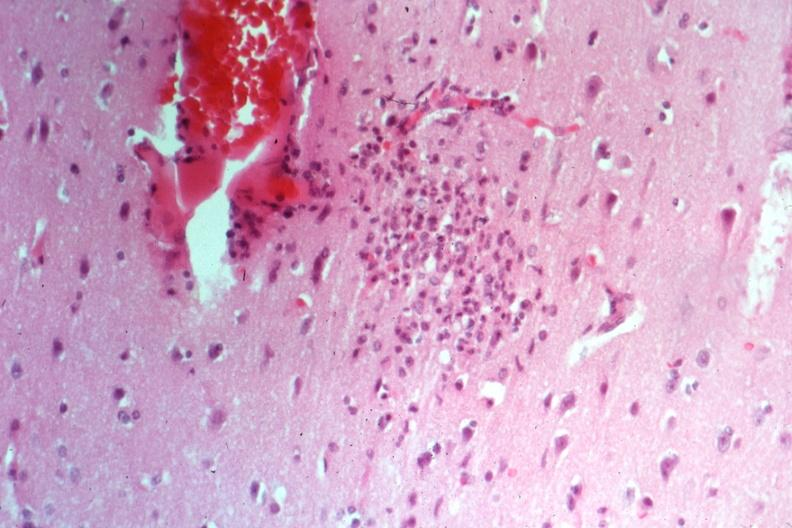s metastatic carcinoma colon present?
Answer the question using a single word or phrase. No 